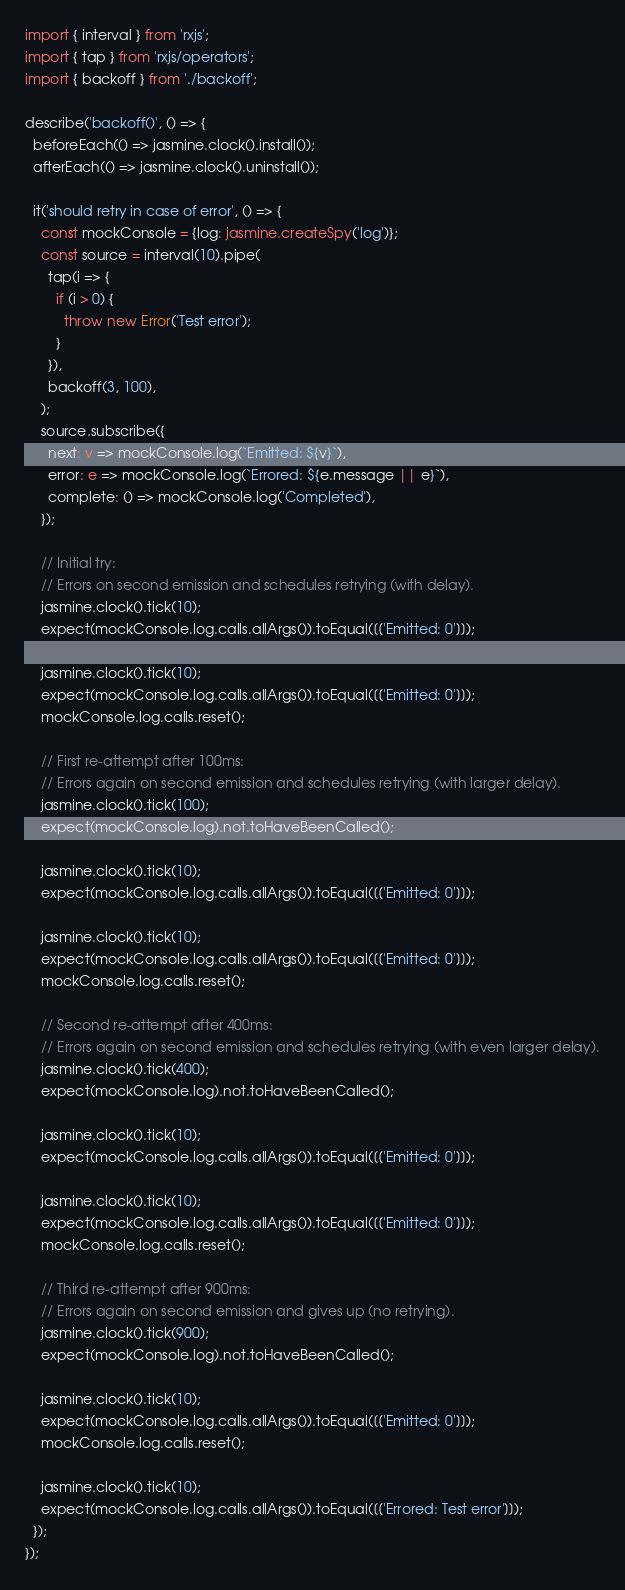Convert code to text. <code><loc_0><loc_0><loc_500><loc_500><_TypeScript_>import { interval } from 'rxjs';
import { tap } from 'rxjs/operators';
import { backoff } from './backoff';

describe('backoff()', () => {
  beforeEach(() => jasmine.clock().install());
  afterEach(() => jasmine.clock().uninstall());

  it('should retry in case of error', () => {
    const mockConsole = {log: jasmine.createSpy('log')};
    const source = interval(10).pipe(
      tap(i => {
        if (i > 0) {
          throw new Error('Test error');
        }
      }),
      backoff(3, 100),
    );
    source.subscribe({
      next: v => mockConsole.log(`Emitted: ${v}`),
      error: e => mockConsole.log(`Errored: ${e.message || e}`),
      complete: () => mockConsole.log('Completed'),
    });

    // Initial try:
    // Errors on second emission and schedules retrying (with delay).
    jasmine.clock().tick(10);
    expect(mockConsole.log.calls.allArgs()).toEqual([['Emitted: 0']]);

    jasmine.clock().tick(10);
    expect(mockConsole.log.calls.allArgs()).toEqual([['Emitted: 0']]);
    mockConsole.log.calls.reset();

    // First re-attempt after 100ms:
    // Errors again on second emission and schedules retrying (with larger delay).
    jasmine.clock().tick(100);
    expect(mockConsole.log).not.toHaveBeenCalled();

    jasmine.clock().tick(10);
    expect(mockConsole.log.calls.allArgs()).toEqual([['Emitted: 0']]);

    jasmine.clock().tick(10);
    expect(mockConsole.log.calls.allArgs()).toEqual([['Emitted: 0']]);
    mockConsole.log.calls.reset();

    // Second re-attempt after 400ms:
    // Errors again on second emission and schedules retrying (with even larger delay).
    jasmine.clock().tick(400);
    expect(mockConsole.log).not.toHaveBeenCalled();

    jasmine.clock().tick(10);
    expect(mockConsole.log.calls.allArgs()).toEqual([['Emitted: 0']]);

    jasmine.clock().tick(10);
    expect(mockConsole.log.calls.allArgs()).toEqual([['Emitted: 0']]);
    mockConsole.log.calls.reset();

    // Third re-attempt after 900ms:
    // Errors again on second emission and gives up (no retrying).
    jasmine.clock().tick(900);
    expect(mockConsole.log).not.toHaveBeenCalled();

    jasmine.clock().tick(10);
    expect(mockConsole.log.calls.allArgs()).toEqual([['Emitted: 0']]);
    mockConsole.log.calls.reset();

    jasmine.clock().tick(10);
    expect(mockConsole.log.calls.allArgs()).toEqual([['Errored: Test error']]);
  });
});
</code> 